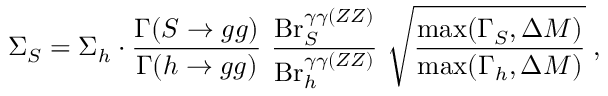<formula> <loc_0><loc_0><loc_500><loc_500>\Sigma _ { S } = \Sigma _ { h } \cdot { \frac { \Gamma ( S \to g g ) } { \Gamma ( h \to g g ) } } { \frac { B r _ { S } ^ { \gamma \gamma ( Z Z ) } } { B r _ { h } ^ { \gamma \gamma ( Z Z ) } } } \sqrt { \frac { \max ( \Gamma _ { S } , \Delta M ) } { \max ( \Gamma _ { h } , \Delta M ) } } \, ,</formula> 